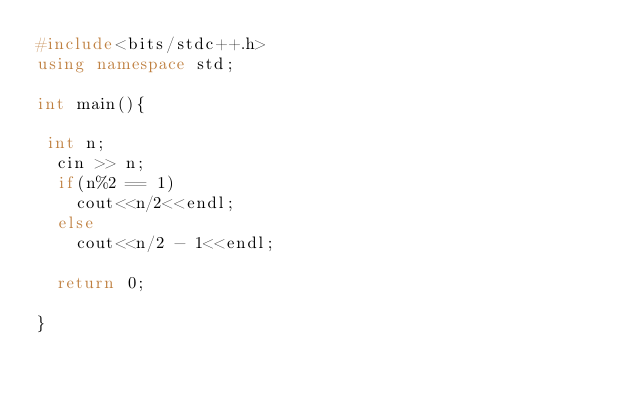Convert code to text. <code><loc_0><loc_0><loc_500><loc_500><_C++_>#include<bits/stdc++.h>
using namespace std;

int main(){
  
 int n;
  cin >> n;
  if(n%2 == 1)
    cout<<n/2<<endl;
  else
    cout<<n/2 - 1<<endl;
  
  return 0;
  
}</code> 